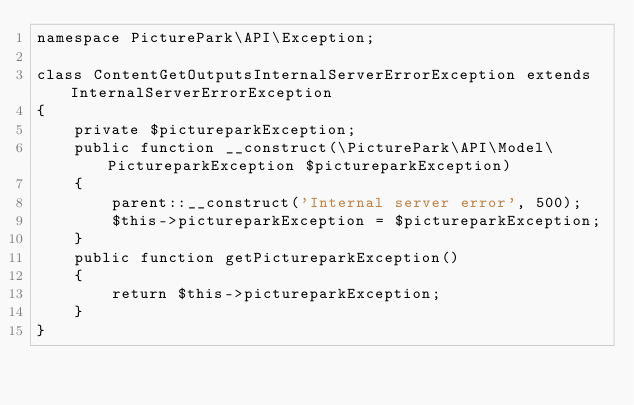<code> <loc_0><loc_0><loc_500><loc_500><_PHP_>namespace PicturePark\API\Exception;

class ContentGetOutputsInternalServerErrorException extends InternalServerErrorException
{
    private $pictureparkException;
    public function __construct(\PicturePark\API\Model\PictureparkException $pictureparkException)
    {
        parent::__construct('Internal server error', 500);
        $this->pictureparkException = $pictureparkException;
    }
    public function getPictureparkException()
    {
        return $this->pictureparkException;
    }
}</code> 